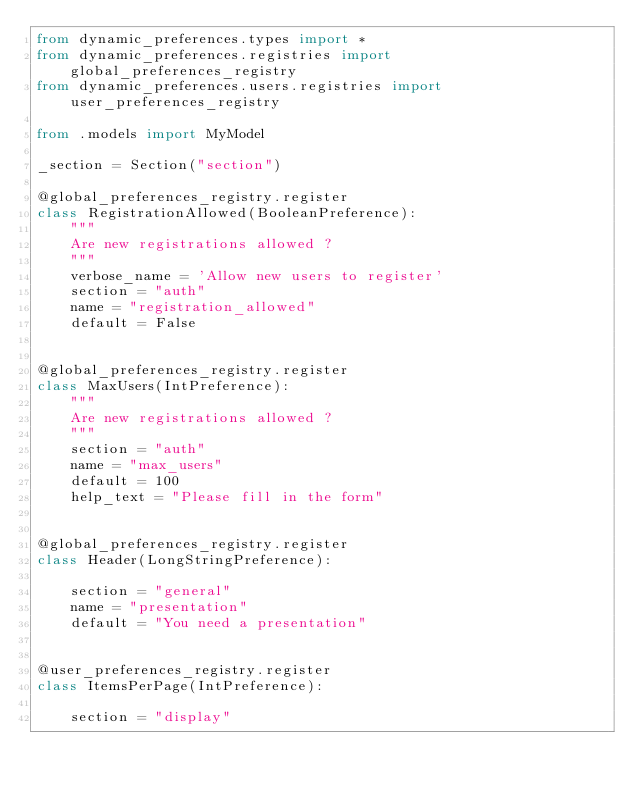<code> <loc_0><loc_0><loc_500><loc_500><_Python_>from dynamic_preferences.types import *
from dynamic_preferences.registries import global_preferences_registry
from dynamic_preferences.users.registries import user_preferences_registry

from .models import MyModel

_section = Section("section")

@global_preferences_registry.register
class RegistrationAllowed(BooleanPreference):
    """
    Are new registrations allowed ?
    """
    verbose_name = 'Allow new users to register'
    section = "auth"
    name = "registration_allowed"
    default = False


@global_preferences_registry.register
class MaxUsers(IntPreference):
    """
    Are new registrations allowed ?
    """
    section = "auth"
    name = "max_users"
    default = 100
    help_text = "Please fill in the form"


@global_preferences_registry.register
class Header(LongStringPreference):

    section = "general"
    name = "presentation"
    default = "You need a presentation"


@user_preferences_registry.register
class ItemsPerPage(IntPreference):

    section = "display"</code> 